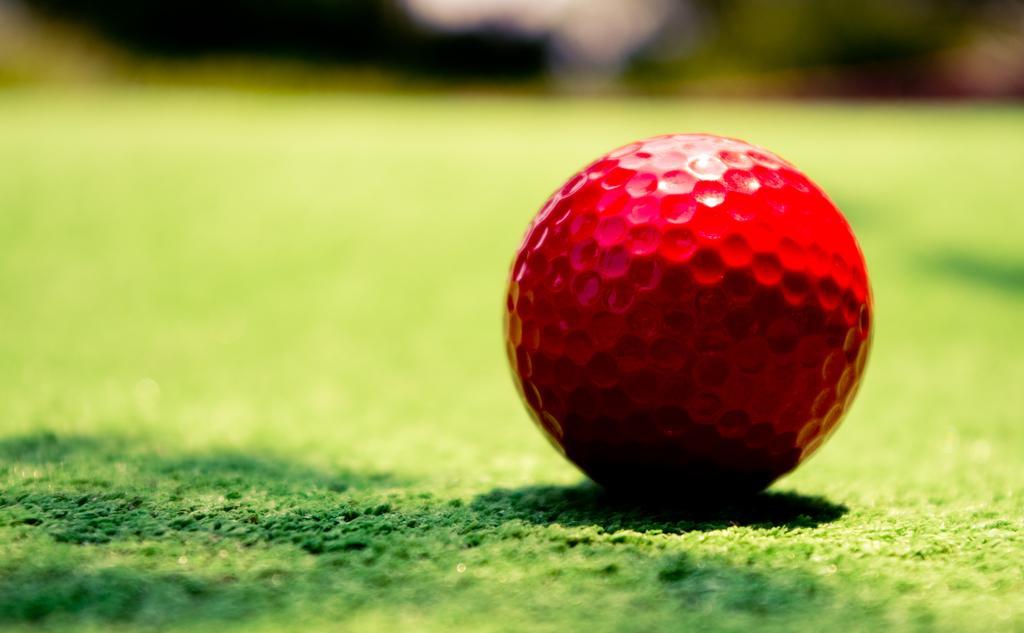Could you give a brief overview of what you see in this image? In the image there is a red golf ball on the grassland. 